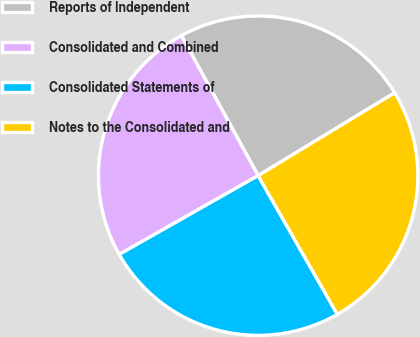Convert chart. <chart><loc_0><loc_0><loc_500><loc_500><pie_chart><fcel>Reports of Independent<fcel>Consolidated and Combined<fcel>Consolidated Statements of<fcel>Notes to the Consolidated and<nl><fcel>24.3%<fcel>25.23%<fcel>25.05%<fcel>25.42%<nl></chart> 